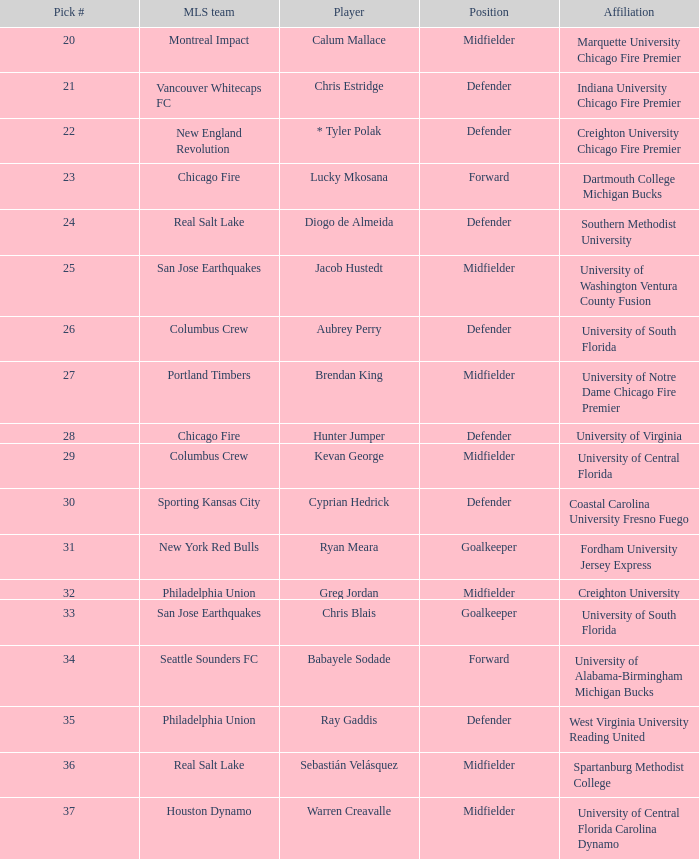What educational institution was kevan george associated with? University of Central Florida. 